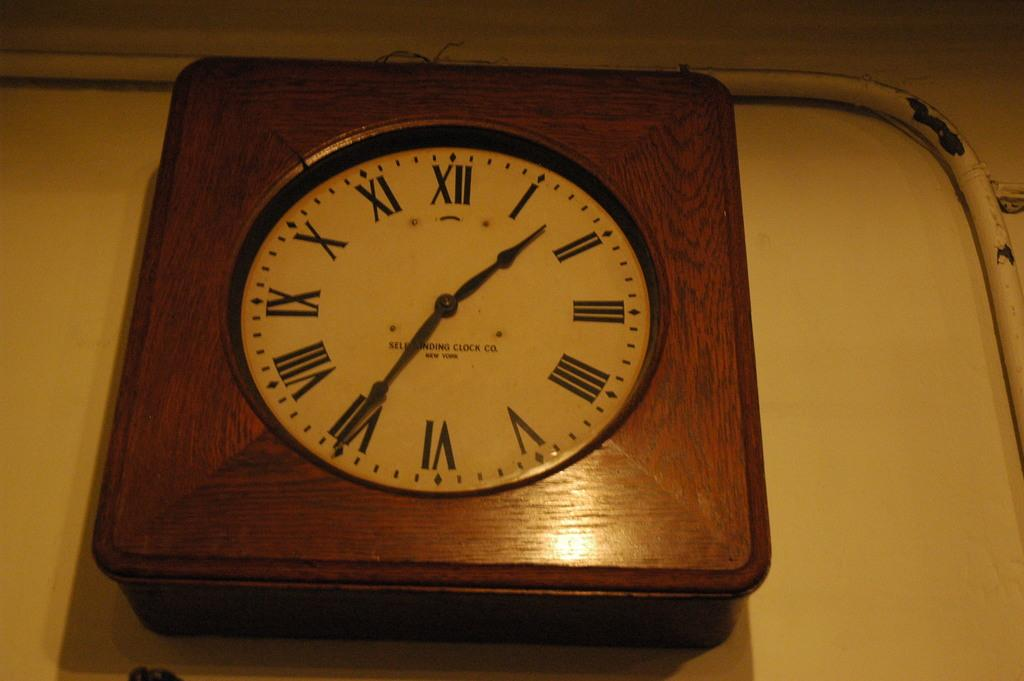Provide a one-sentence caption for the provided image. An old analog clock with roman numerals reads Self Winding Clock Co. New York. 